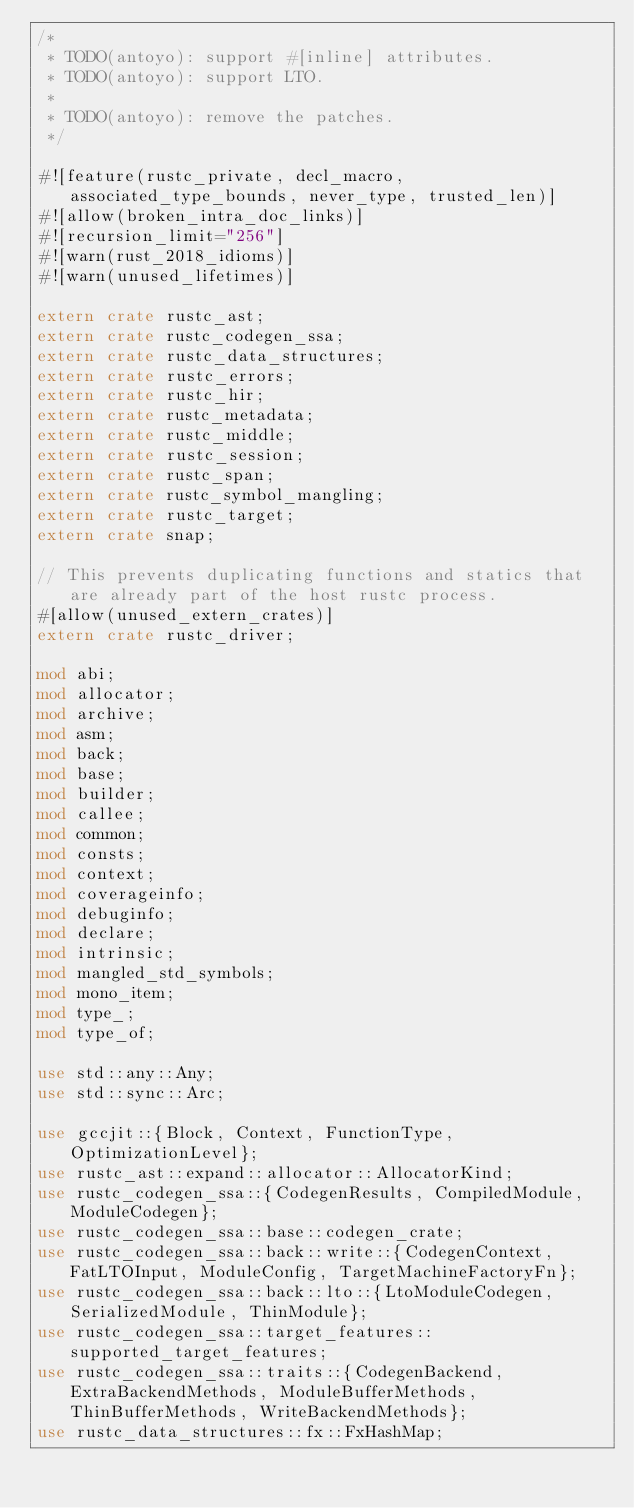<code> <loc_0><loc_0><loc_500><loc_500><_Rust_>/*
 * TODO(antoyo): support #[inline] attributes.
 * TODO(antoyo): support LTO.
 *
 * TODO(antoyo): remove the patches.
 */

#![feature(rustc_private, decl_macro, associated_type_bounds, never_type, trusted_len)]
#![allow(broken_intra_doc_links)]
#![recursion_limit="256"]
#![warn(rust_2018_idioms)]
#![warn(unused_lifetimes)]

extern crate rustc_ast;
extern crate rustc_codegen_ssa;
extern crate rustc_data_structures;
extern crate rustc_errors;
extern crate rustc_hir;
extern crate rustc_metadata;
extern crate rustc_middle;
extern crate rustc_session;
extern crate rustc_span;
extern crate rustc_symbol_mangling;
extern crate rustc_target;
extern crate snap;

// This prevents duplicating functions and statics that are already part of the host rustc process.
#[allow(unused_extern_crates)]
extern crate rustc_driver;

mod abi;
mod allocator;
mod archive;
mod asm;
mod back;
mod base;
mod builder;
mod callee;
mod common;
mod consts;
mod context;
mod coverageinfo;
mod debuginfo;
mod declare;
mod intrinsic;
mod mangled_std_symbols;
mod mono_item;
mod type_;
mod type_of;

use std::any::Any;
use std::sync::Arc;

use gccjit::{Block, Context, FunctionType, OptimizationLevel};
use rustc_ast::expand::allocator::AllocatorKind;
use rustc_codegen_ssa::{CodegenResults, CompiledModule, ModuleCodegen};
use rustc_codegen_ssa::base::codegen_crate;
use rustc_codegen_ssa::back::write::{CodegenContext, FatLTOInput, ModuleConfig, TargetMachineFactoryFn};
use rustc_codegen_ssa::back::lto::{LtoModuleCodegen, SerializedModule, ThinModule};
use rustc_codegen_ssa::target_features::supported_target_features;
use rustc_codegen_ssa::traits::{CodegenBackend, ExtraBackendMethods, ModuleBufferMethods, ThinBufferMethods, WriteBackendMethods};
use rustc_data_structures::fx::FxHashMap;</code> 